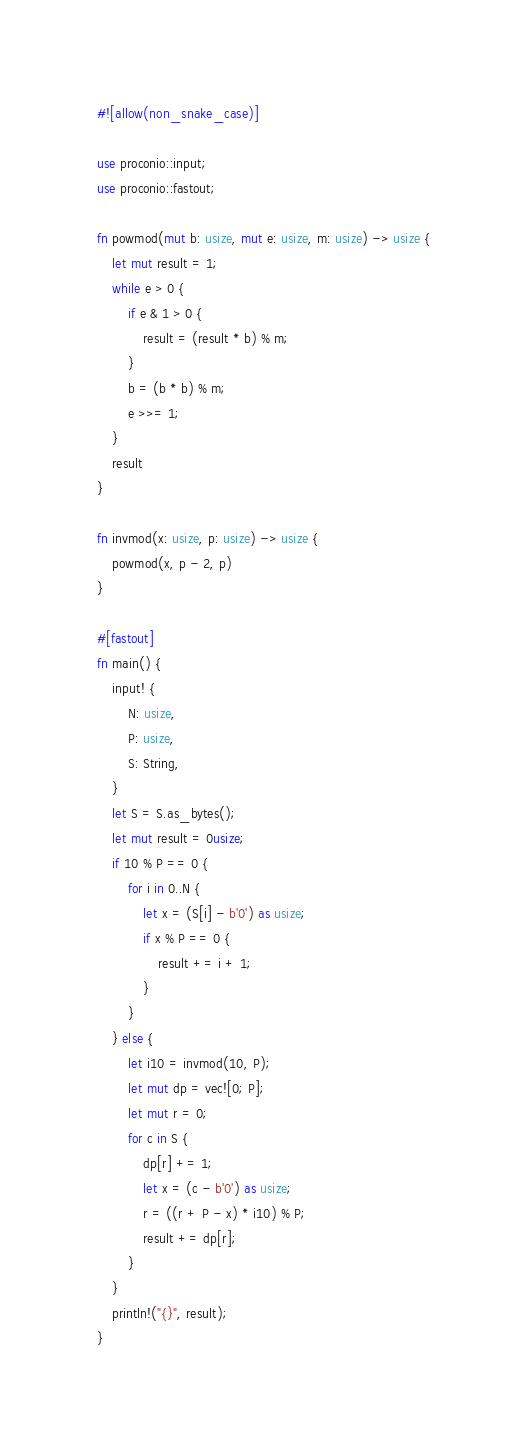Convert code to text. <code><loc_0><loc_0><loc_500><loc_500><_Rust_>#![allow(non_snake_case)]

use proconio::input;
use proconio::fastout;

fn powmod(mut b: usize, mut e: usize, m: usize) -> usize {
    let mut result = 1;
    while e > 0 {
        if e & 1 > 0 {
            result = (result * b) % m;
        }
        b = (b * b) % m;
        e >>= 1;
    }
    result
}

fn invmod(x: usize, p: usize) -> usize {
    powmod(x, p - 2, p)
}

#[fastout]
fn main() {
    input! {
        N: usize,
        P: usize,
        S: String,
    }
    let S = S.as_bytes();
    let mut result = 0usize;
    if 10 % P == 0 {
        for i in 0..N {
            let x = (S[i] - b'0') as usize;
            if x % P == 0 {
                result += i + 1;
            }
        }
    } else {
        let i10 = invmod(10, P);
        let mut dp = vec![0; P];
        let mut r = 0;
        for c in S {
            dp[r] += 1;
            let x = (c - b'0') as usize;
            r = ((r + P - x) * i10) % P;
            result += dp[r];
        }
    }
    println!("{}", result);
}
</code> 